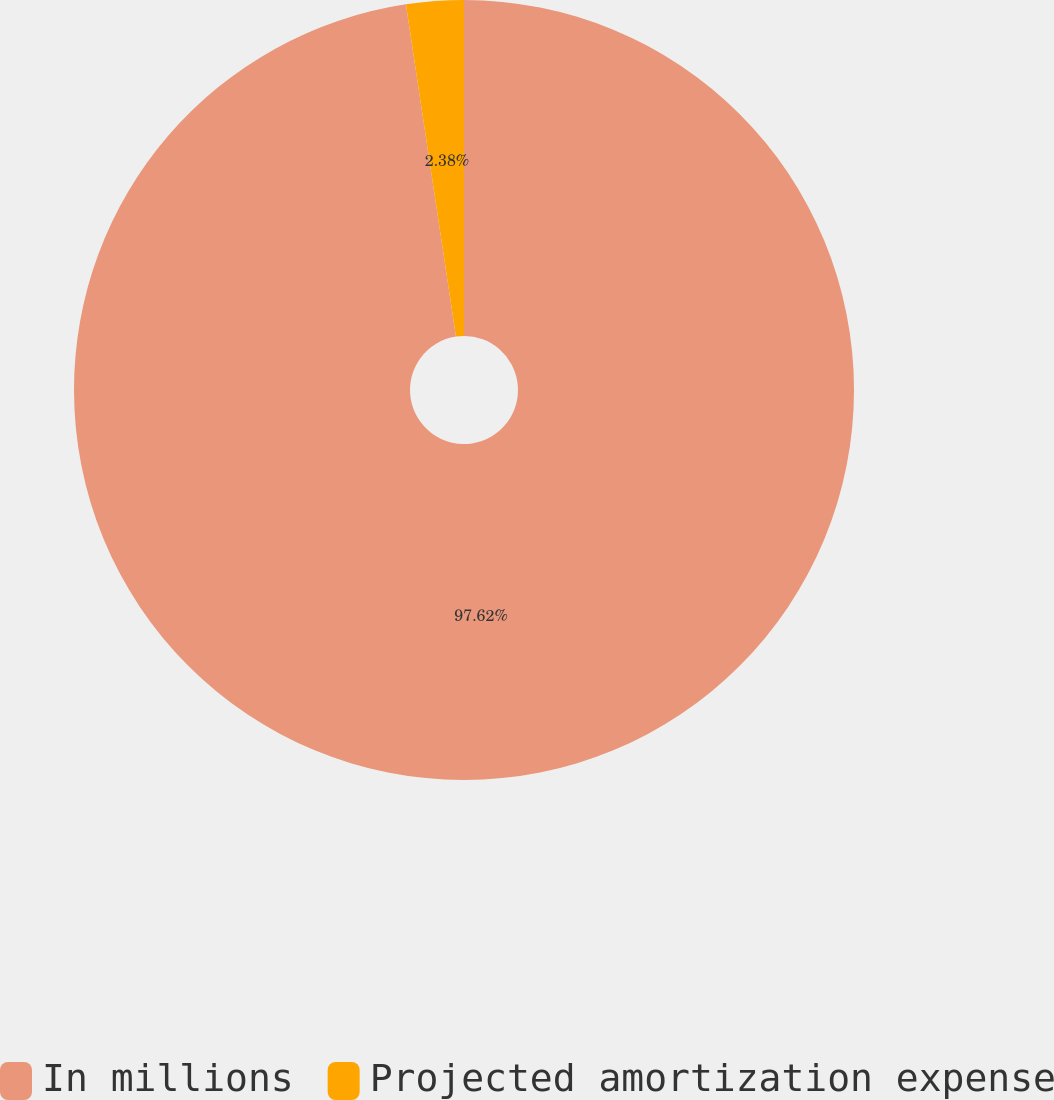<chart> <loc_0><loc_0><loc_500><loc_500><pie_chart><fcel>In millions<fcel>Projected amortization expense<nl><fcel>97.62%<fcel>2.38%<nl></chart> 